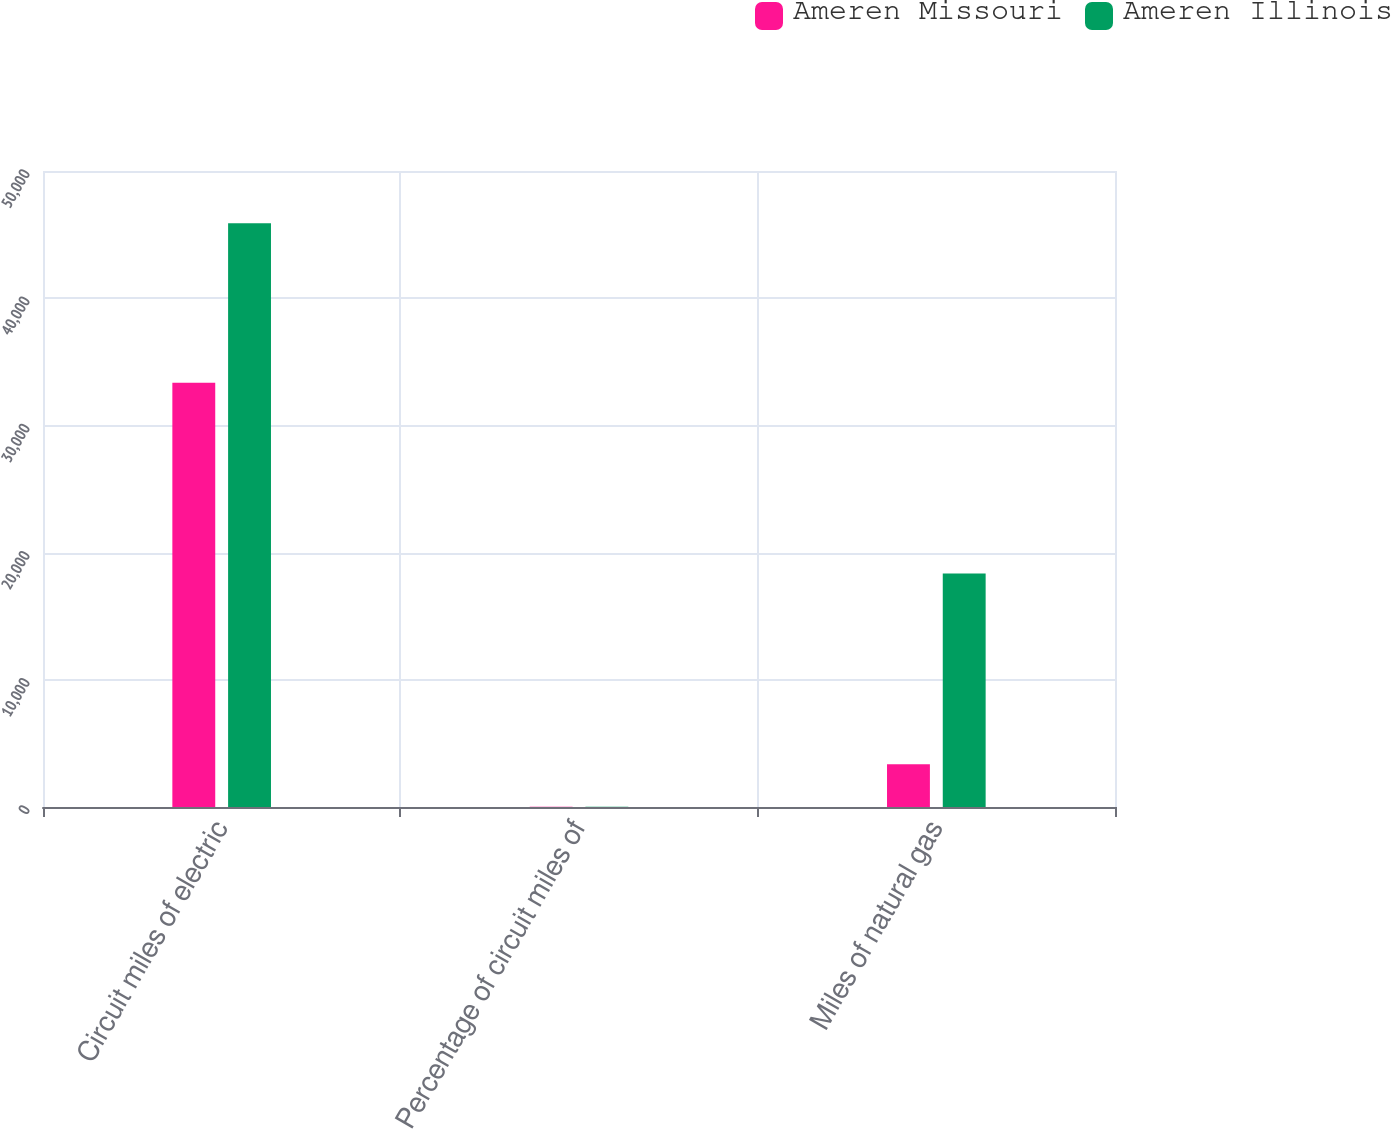<chart> <loc_0><loc_0><loc_500><loc_500><stacked_bar_chart><ecel><fcel>Circuit miles of electric<fcel>Percentage of circuit miles of<fcel>Miles of natural gas<nl><fcel>Ameren Missouri<fcel>33346<fcel>23<fcel>3357<nl><fcel>Ameren Illinois<fcel>45897<fcel>15<fcel>18364<nl></chart> 